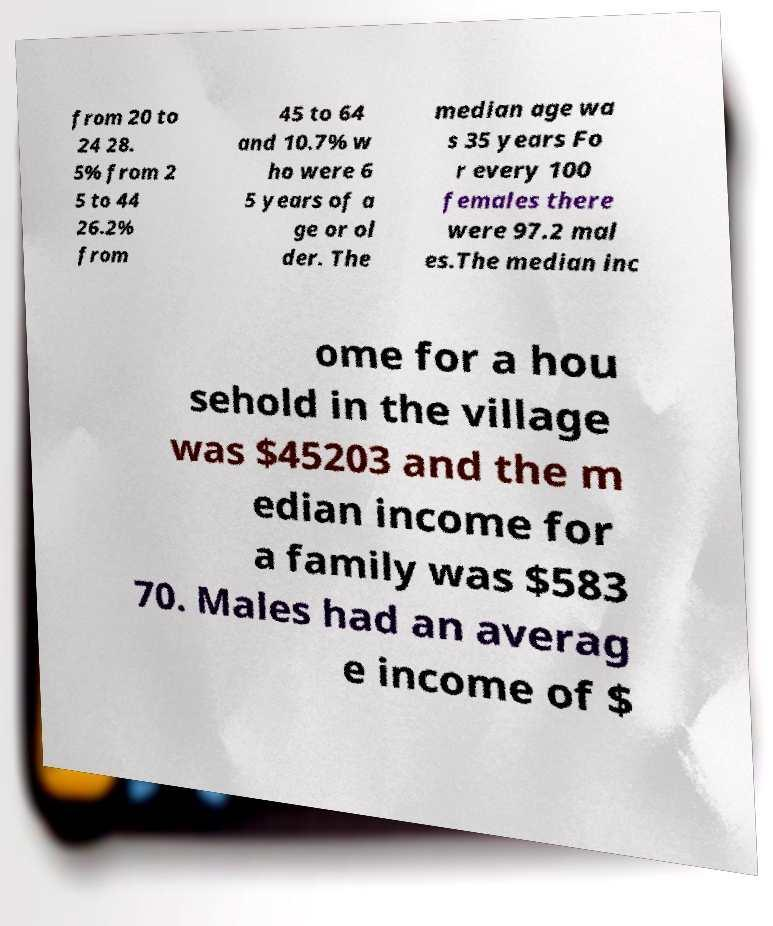Please read and relay the text visible in this image. What does it say? from 20 to 24 28. 5% from 2 5 to 44 26.2% from 45 to 64 and 10.7% w ho were 6 5 years of a ge or ol der. The median age wa s 35 years Fo r every 100 females there were 97.2 mal es.The median inc ome for a hou sehold in the village was $45203 and the m edian income for a family was $583 70. Males had an averag e income of $ 